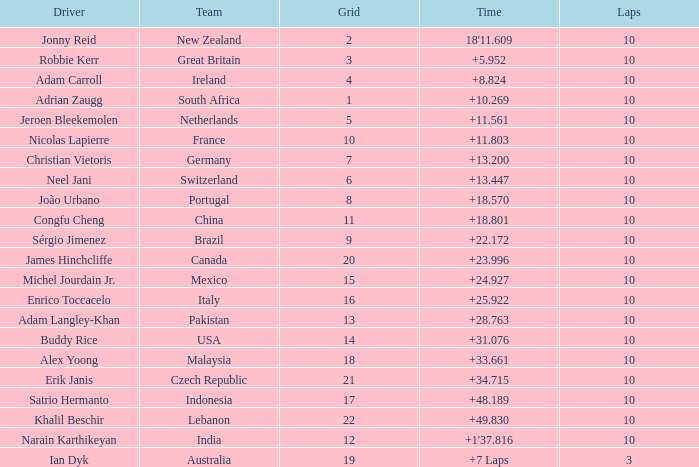What team had 10 Labs and the Driver was Alex Yoong? Malaysia. 